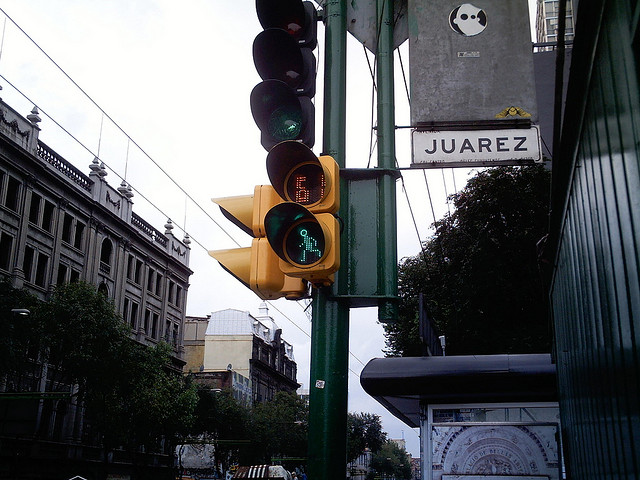Extract all visible text content from this image. 6 JUAREZ 